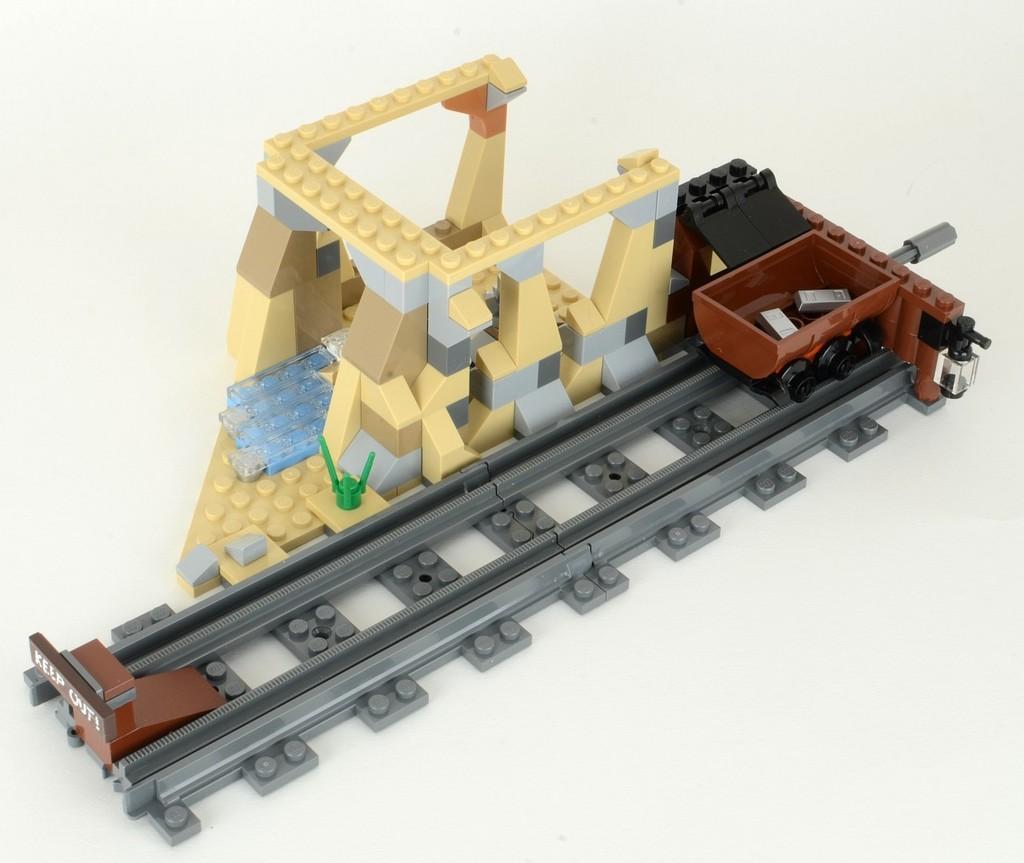How would you summarize this image in a sentence or two? In this image we can see some Lego toys which are placed on the surface. In that we can see the track and a trolley on it. 